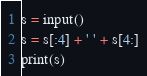Convert code to text. <code><loc_0><loc_0><loc_500><loc_500><_Python_>s = input()
s = s[:4] + ' ' + s[4:]
print(s)</code> 